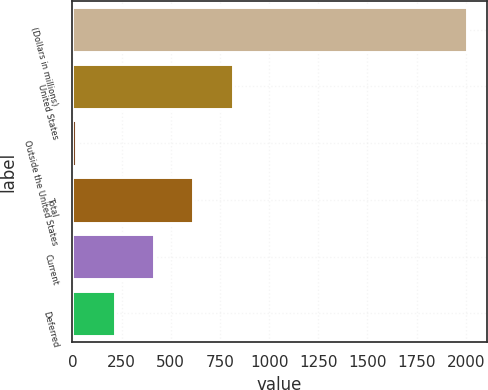<chart> <loc_0><loc_0><loc_500><loc_500><bar_chart><fcel>(Dollars in millions)<fcel>United States<fcel>Outside the United States<fcel>Total<fcel>Current<fcel>Deferred<nl><fcel>2007<fcel>814.2<fcel>19<fcel>615.4<fcel>416.6<fcel>217.8<nl></chart> 